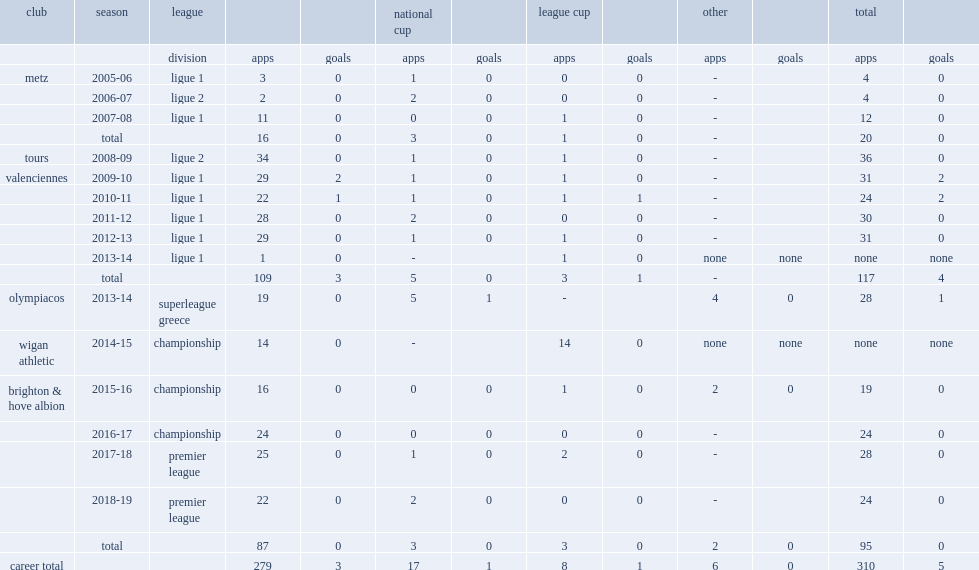In 2009, which club did gaetan bong sign with? Valenciennes. 